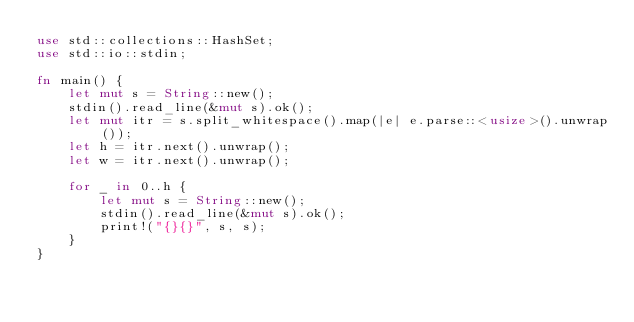Convert code to text. <code><loc_0><loc_0><loc_500><loc_500><_Rust_>use std::collections::HashSet;
use std::io::stdin;

fn main() {
    let mut s = String::new();
    stdin().read_line(&mut s).ok();
    let mut itr = s.split_whitespace().map(|e| e.parse::<usize>().unwrap());
    let h = itr.next().unwrap();
    let w = itr.next().unwrap();

    for _ in 0..h {
        let mut s = String::new();
        stdin().read_line(&mut s).ok();
        print!("{}{}", s, s);
    }
}
</code> 